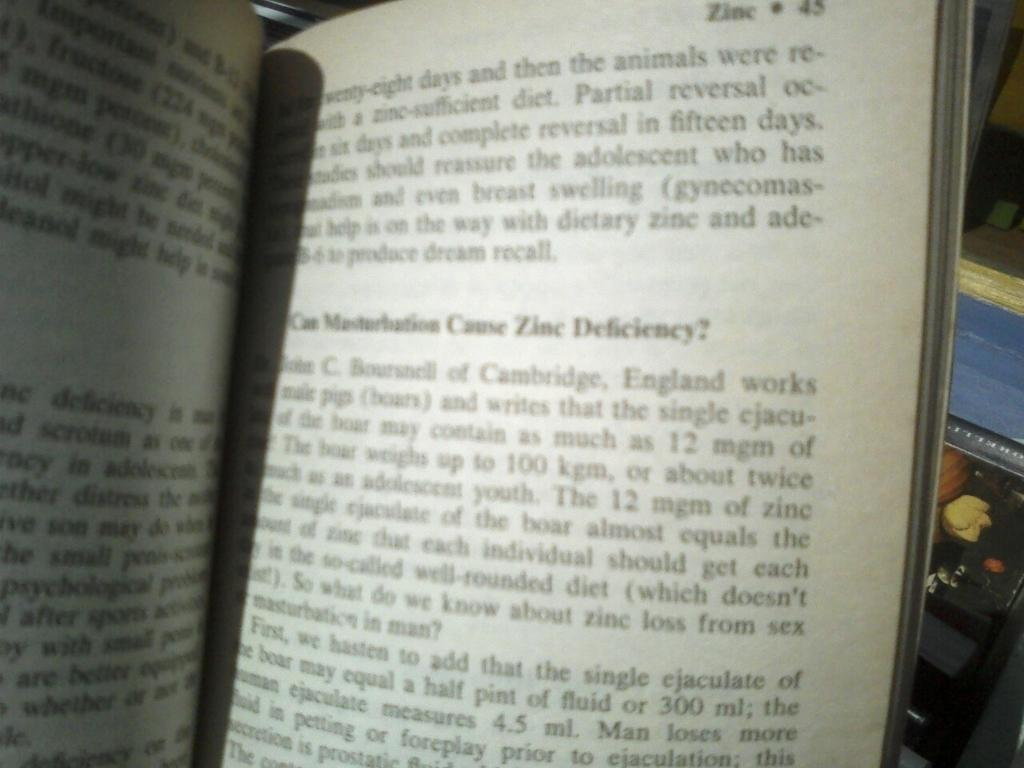<image>
Summarize the visual content of the image. A chapter book about Zinc and the deficiency 